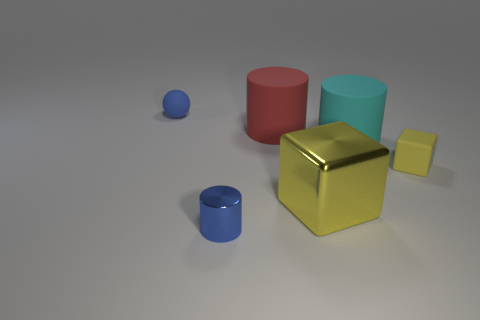Add 2 small objects. How many objects exist? 8 Subtract all blocks. How many objects are left? 4 Add 6 blue things. How many blue things exist? 8 Subtract 0 red cubes. How many objects are left? 6 Subtract all large cyan objects. Subtract all rubber things. How many objects are left? 1 Add 5 small cubes. How many small cubes are left? 6 